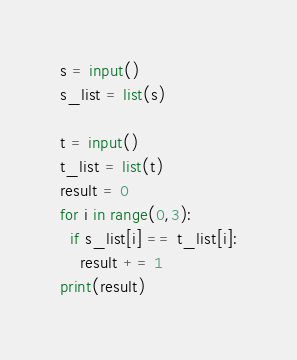<code> <loc_0><loc_0><loc_500><loc_500><_Python_>s = input()
s_list = list(s)

t = input()
t_list = list(t)
result = 0
for i in range(0,3):
  if s_list[i] == t_list[i]:
    result += 1
print(result)</code> 